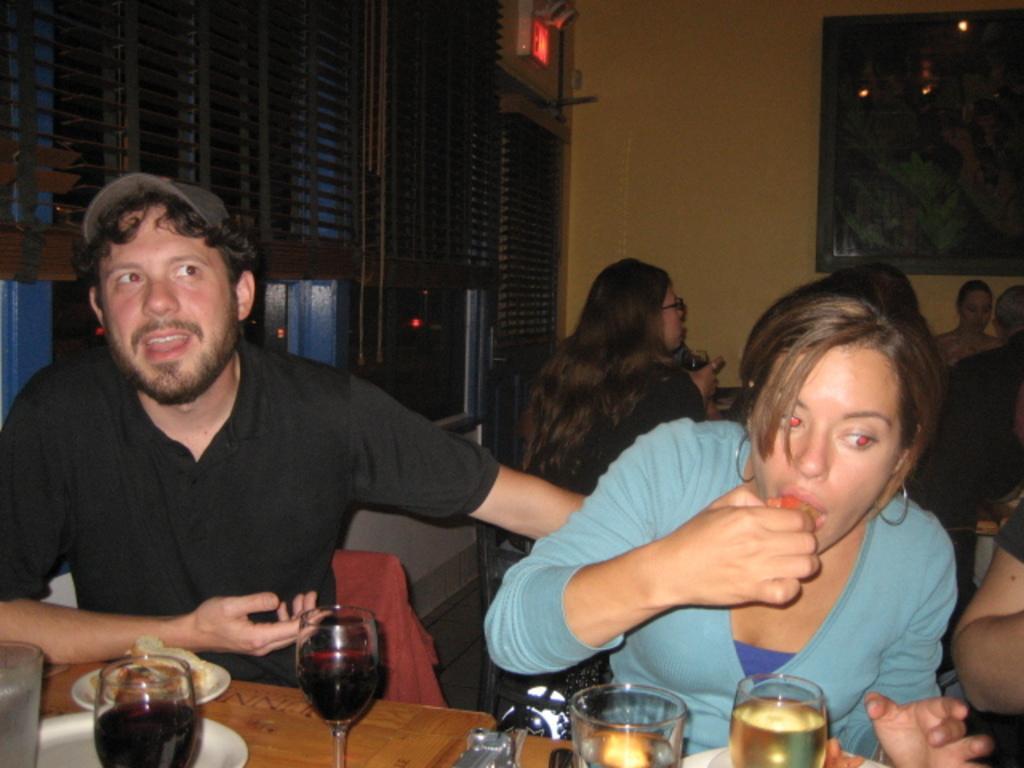Please provide a concise description of this image. In the image in the center we can see two people were sitting on the chair. In front of them,there is a table. On the table,we can see wine glasses,plates,some food items and few other objects. In the background there is a wall,window blinds and few people were sitting on the chair. 